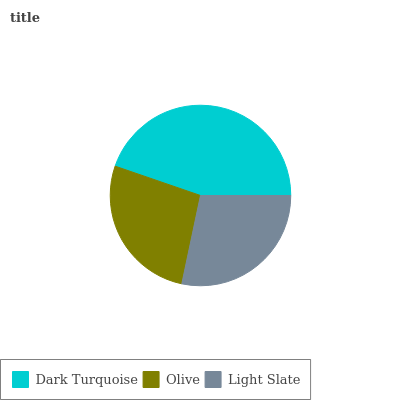Is Olive the minimum?
Answer yes or no. Yes. Is Dark Turquoise the maximum?
Answer yes or no. Yes. Is Light Slate the minimum?
Answer yes or no. No. Is Light Slate the maximum?
Answer yes or no. No. Is Light Slate greater than Olive?
Answer yes or no. Yes. Is Olive less than Light Slate?
Answer yes or no. Yes. Is Olive greater than Light Slate?
Answer yes or no. No. Is Light Slate less than Olive?
Answer yes or no. No. Is Light Slate the high median?
Answer yes or no. Yes. Is Light Slate the low median?
Answer yes or no. Yes. Is Olive the high median?
Answer yes or no. No. Is Dark Turquoise the low median?
Answer yes or no. No. 